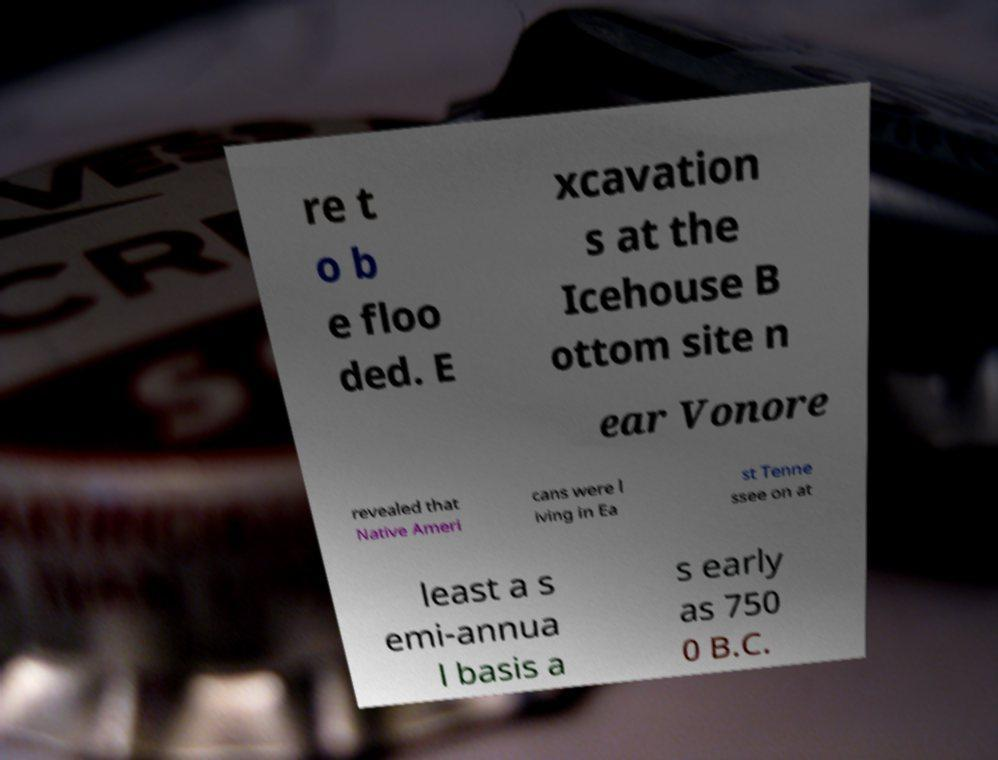Can you read and provide the text displayed in the image?This photo seems to have some interesting text. Can you extract and type it out for me? re t o b e floo ded. E xcavation s at the Icehouse B ottom site n ear Vonore revealed that Native Ameri cans were l iving in Ea st Tenne ssee on at least a s emi-annua l basis a s early as 750 0 B.C. 